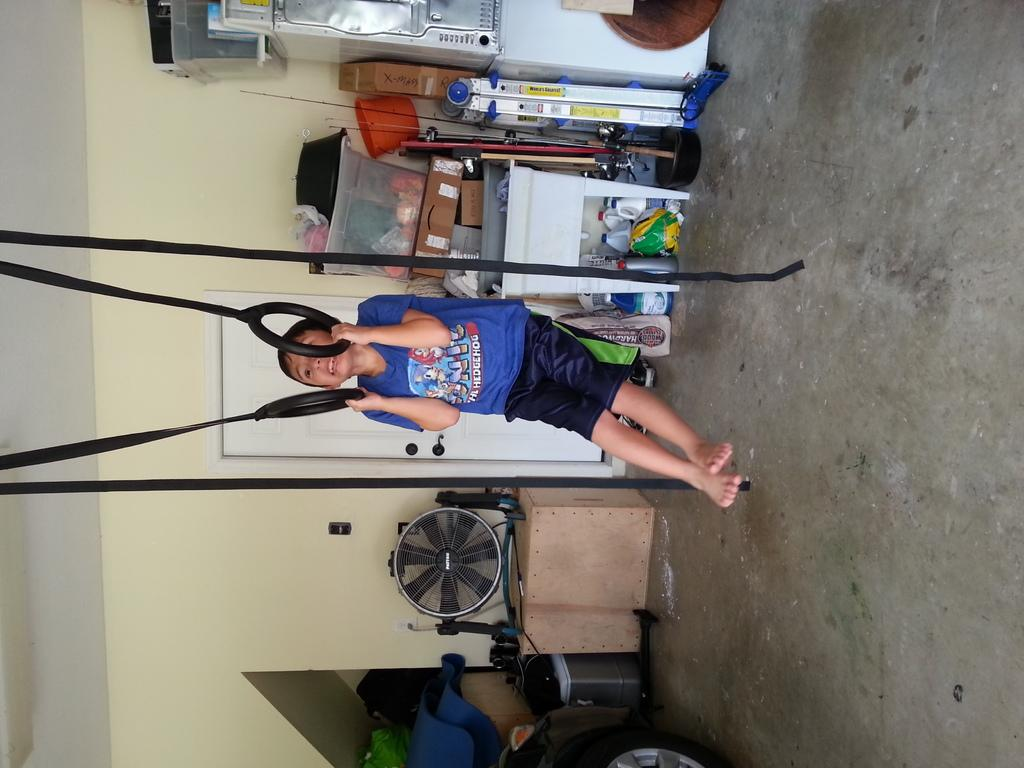What is the main subject of the image? The main subject of the image is a boy. What is the boy holding in the image? The boy is holding rings with his hands. What type of appliance can be seen in the image? There is a fan in the image. What type of container is present in the image? There is a box in the image. What type of items are visible in the image? There are bags, bottles, and baskets in the image. What is visible in the background of the image? There is a wall in the background of the image. How many different types of objects can be seen in the image? There are at least nine different types of objects in the image, including the boy, rings, fan, box, bags, bottles, baskets, and other objects. What type of acoustics can be heard in the image? There is no mention of acoustics in the image, so it cannot be heard. --- Facts: 1. There is a car in the image. 2. The car is red. 3. The car has four wheels. 4. The car has a sunroof. 5. The car has a spoiler. 6. The car has a license plate. 7. The car has a front bumper. 8. The car has a rear bumper. 9. The car has a trunk. 10. The car has a windshield. 1. The car has a rearview mirror. 12. The car has a steering wheel. 13. The car has a dashboard. 14. The car has a set of seats. 15. The car has a set of seatbelts. 16. The car has a set of tires. 17. The car has a set of headlights. 18. The car has a set of taillights. 19. The car has a set of side mirrors. 120. The car has a set of doors. Absurd Topics: unicorn, rainbow, stars Conversation: What type of vehicle is in the image? There is a car in the image. What is the color of the car in the image? The car in the image is red. How many wheels does the car in the image have? The car in the image has four wheels. What type of feature does the car in the image have? The car in the image has a sunroof. What type of feature does the car in the image have? The car in the image has a spoiler. What type of feature does the car in the image have? The car in the image has a license plate 